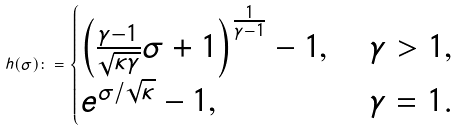<formula> <loc_0><loc_0><loc_500><loc_500>h ( \sigma ) \colon = \begin{cases} \left ( \frac { \gamma - 1 } { \sqrt { \kappa \gamma } } \sigma + 1 \right ) ^ { \frac { 1 } { \gamma - 1 } } - 1 , \ & \gamma > 1 , \\ e ^ { \sigma / \sqrt { \kappa } } - 1 , \ & \gamma = 1 . \end{cases}</formula> 